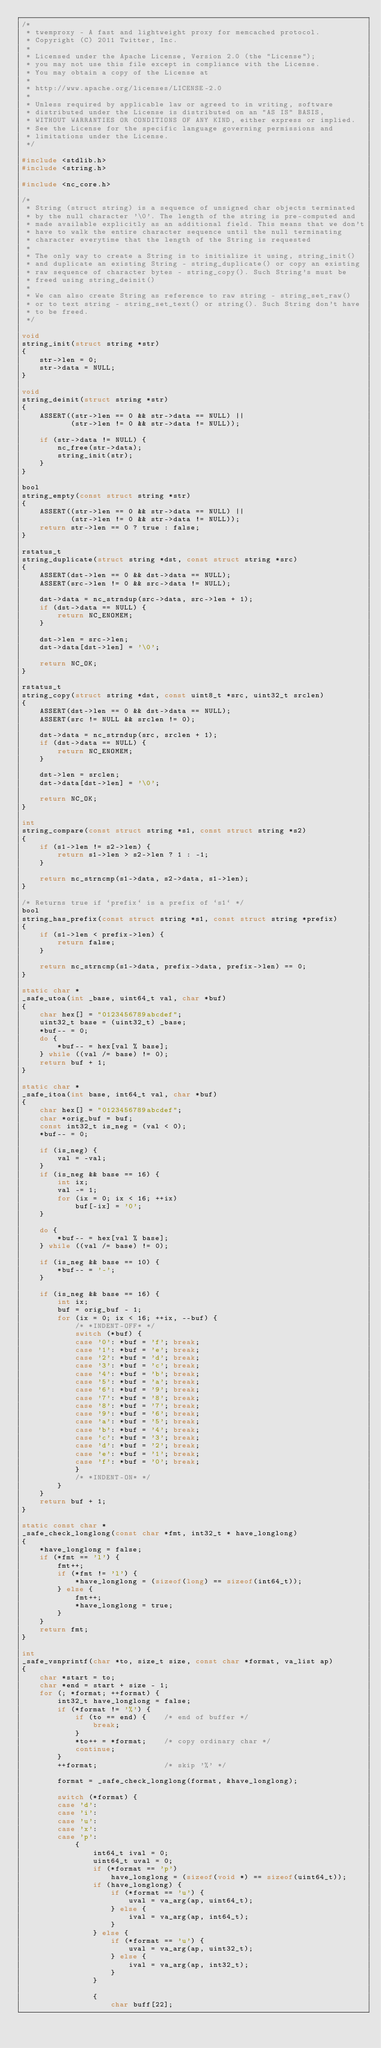Convert code to text. <code><loc_0><loc_0><loc_500><loc_500><_C_>/*
 * twemproxy - A fast and lightweight proxy for memcached protocol.
 * Copyright (C) 2011 Twitter, Inc.
 *
 * Licensed under the Apache License, Version 2.0 (the "License");
 * you may not use this file except in compliance with the License.
 * You may obtain a copy of the License at
 *
 * http://www.apache.org/licenses/LICENSE-2.0
 *
 * Unless required by applicable law or agreed to in writing, software
 * distributed under the License is distributed on an "AS IS" BASIS,
 * WITHOUT WARRANTIES OR CONDITIONS OF ANY KIND, either express or implied.
 * See the License for the specific language governing permissions and
 * limitations under the License.
 */

#include <stdlib.h>
#include <string.h>

#include <nc_core.h>

/*
 * String (struct string) is a sequence of unsigned char objects terminated
 * by the null character '\0'. The length of the string is pre-computed and
 * made available explicitly as an additional field. This means that we don't
 * have to walk the entire character sequence until the null terminating
 * character everytime that the length of the String is requested
 *
 * The only way to create a String is to initialize it using, string_init()
 * and duplicate an existing String - string_duplicate() or copy an existing
 * raw sequence of character bytes - string_copy(). Such String's must be
 * freed using string_deinit()
 *
 * We can also create String as reference to raw string - string_set_raw()
 * or to text string - string_set_text() or string(). Such String don't have
 * to be freed.
 */

void
string_init(struct string *str)
{
    str->len = 0;
    str->data = NULL;
}

void
string_deinit(struct string *str)
{
    ASSERT((str->len == 0 && str->data == NULL) ||
           (str->len != 0 && str->data != NULL));

    if (str->data != NULL) {
        nc_free(str->data);
        string_init(str);
    }
}

bool
string_empty(const struct string *str)
{
    ASSERT((str->len == 0 && str->data == NULL) ||
           (str->len != 0 && str->data != NULL));
    return str->len == 0 ? true : false;
}

rstatus_t
string_duplicate(struct string *dst, const struct string *src)
{
    ASSERT(dst->len == 0 && dst->data == NULL);
    ASSERT(src->len != 0 && src->data != NULL);

    dst->data = nc_strndup(src->data, src->len + 1);
    if (dst->data == NULL) {
        return NC_ENOMEM;
    }

    dst->len = src->len;
    dst->data[dst->len] = '\0';

    return NC_OK;
}

rstatus_t
string_copy(struct string *dst, const uint8_t *src, uint32_t srclen)
{
    ASSERT(dst->len == 0 && dst->data == NULL);
    ASSERT(src != NULL && srclen != 0);

    dst->data = nc_strndup(src, srclen + 1);
    if (dst->data == NULL) {
        return NC_ENOMEM;
    }

    dst->len = srclen;
    dst->data[dst->len] = '\0';

    return NC_OK;
}

int
string_compare(const struct string *s1, const struct string *s2)
{
    if (s1->len != s2->len) {
        return s1->len > s2->len ? 1 : -1;
    }

    return nc_strncmp(s1->data, s2->data, s1->len);
}

/* Returns true if `prefix` is a prefix of `s1` */
bool
string_has_prefix(const struct string *s1, const struct string *prefix)
{
    if (s1->len < prefix->len) {
        return false;
    }

    return nc_strncmp(s1->data, prefix->data, prefix->len) == 0;
}

static char *
_safe_utoa(int _base, uint64_t val, char *buf)
{
    char hex[] = "0123456789abcdef";
    uint32_t base = (uint32_t) _base;
    *buf-- = 0;
    do {
        *buf-- = hex[val % base];
    } while ((val /= base) != 0);
    return buf + 1;
}

static char *
_safe_itoa(int base, int64_t val, char *buf)
{
    char hex[] = "0123456789abcdef";
    char *orig_buf = buf;
    const int32_t is_neg = (val < 0);
    *buf-- = 0;

    if (is_neg) {
        val = -val;
    }
    if (is_neg && base == 16) {
        int ix;
        val -= 1;
        for (ix = 0; ix < 16; ++ix)
            buf[-ix] = '0';
    }

    do {
        *buf-- = hex[val % base];
    } while ((val /= base) != 0);

    if (is_neg && base == 10) {
        *buf-- = '-';
    }

    if (is_neg && base == 16) {
        int ix;
        buf = orig_buf - 1;
        for (ix = 0; ix < 16; ++ix, --buf) {
            /* *INDENT-OFF* */
            switch (*buf) {
            case '0': *buf = 'f'; break;
            case '1': *buf = 'e'; break;
            case '2': *buf = 'd'; break;
            case '3': *buf = 'c'; break;
            case '4': *buf = 'b'; break;
            case '5': *buf = 'a'; break;
            case '6': *buf = '9'; break;
            case '7': *buf = '8'; break;
            case '8': *buf = '7'; break;
            case '9': *buf = '6'; break;
            case 'a': *buf = '5'; break;
            case 'b': *buf = '4'; break;
            case 'c': *buf = '3'; break;
            case 'd': *buf = '2'; break;
            case 'e': *buf = '1'; break;
            case 'f': *buf = '0'; break;
            }
            /* *INDENT-ON* */
        }
    }
    return buf + 1;
}

static const char *
_safe_check_longlong(const char *fmt, int32_t * have_longlong)
{
    *have_longlong = false;
    if (*fmt == 'l') {
        fmt++;
        if (*fmt != 'l') {
            *have_longlong = (sizeof(long) == sizeof(int64_t));
        } else {
            fmt++;
            *have_longlong = true;
        }
    }
    return fmt;
}

int
_safe_vsnprintf(char *to, size_t size, const char *format, va_list ap)
{
    char *start = to;
    char *end = start + size - 1;
    for (; *format; ++format) {
        int32_t have_longlong = false;
        if (*format != '%') {
            if (to == end) {    /* end of buffer */
                break;
            }
            *to++ = *format;    /* copy ordinary char */
            continue;
        }
        ++format;               /* skip '%' */

        format = _safe_check_longlong(format, &have_longlong);

        switch (*format) {
        case 'd':
        case 'i':
        case 'u':
        case 'x':
        case 'p':
            {
                int64_t ival = 0;
                uint64_t uval = 0;
                if (*format == 'p')
                    have_longlong = (sizeof(void *) == sizeof(uint64_t));
                if (have_longlong) {
                    if (*format == 'u') {
                        uval = va_arg(ap, uint64_t);
                    } else {
                        ival = va_arg(ap, int64_t);
                    }
                } else {
                    if (*format == 'u') {
                        uval = va_arg(ap, uint32_t);
                    } else {
                        ival = va_arg(ap, int32_t);
                    }
                }

                {
                    char buff[22];</code> 